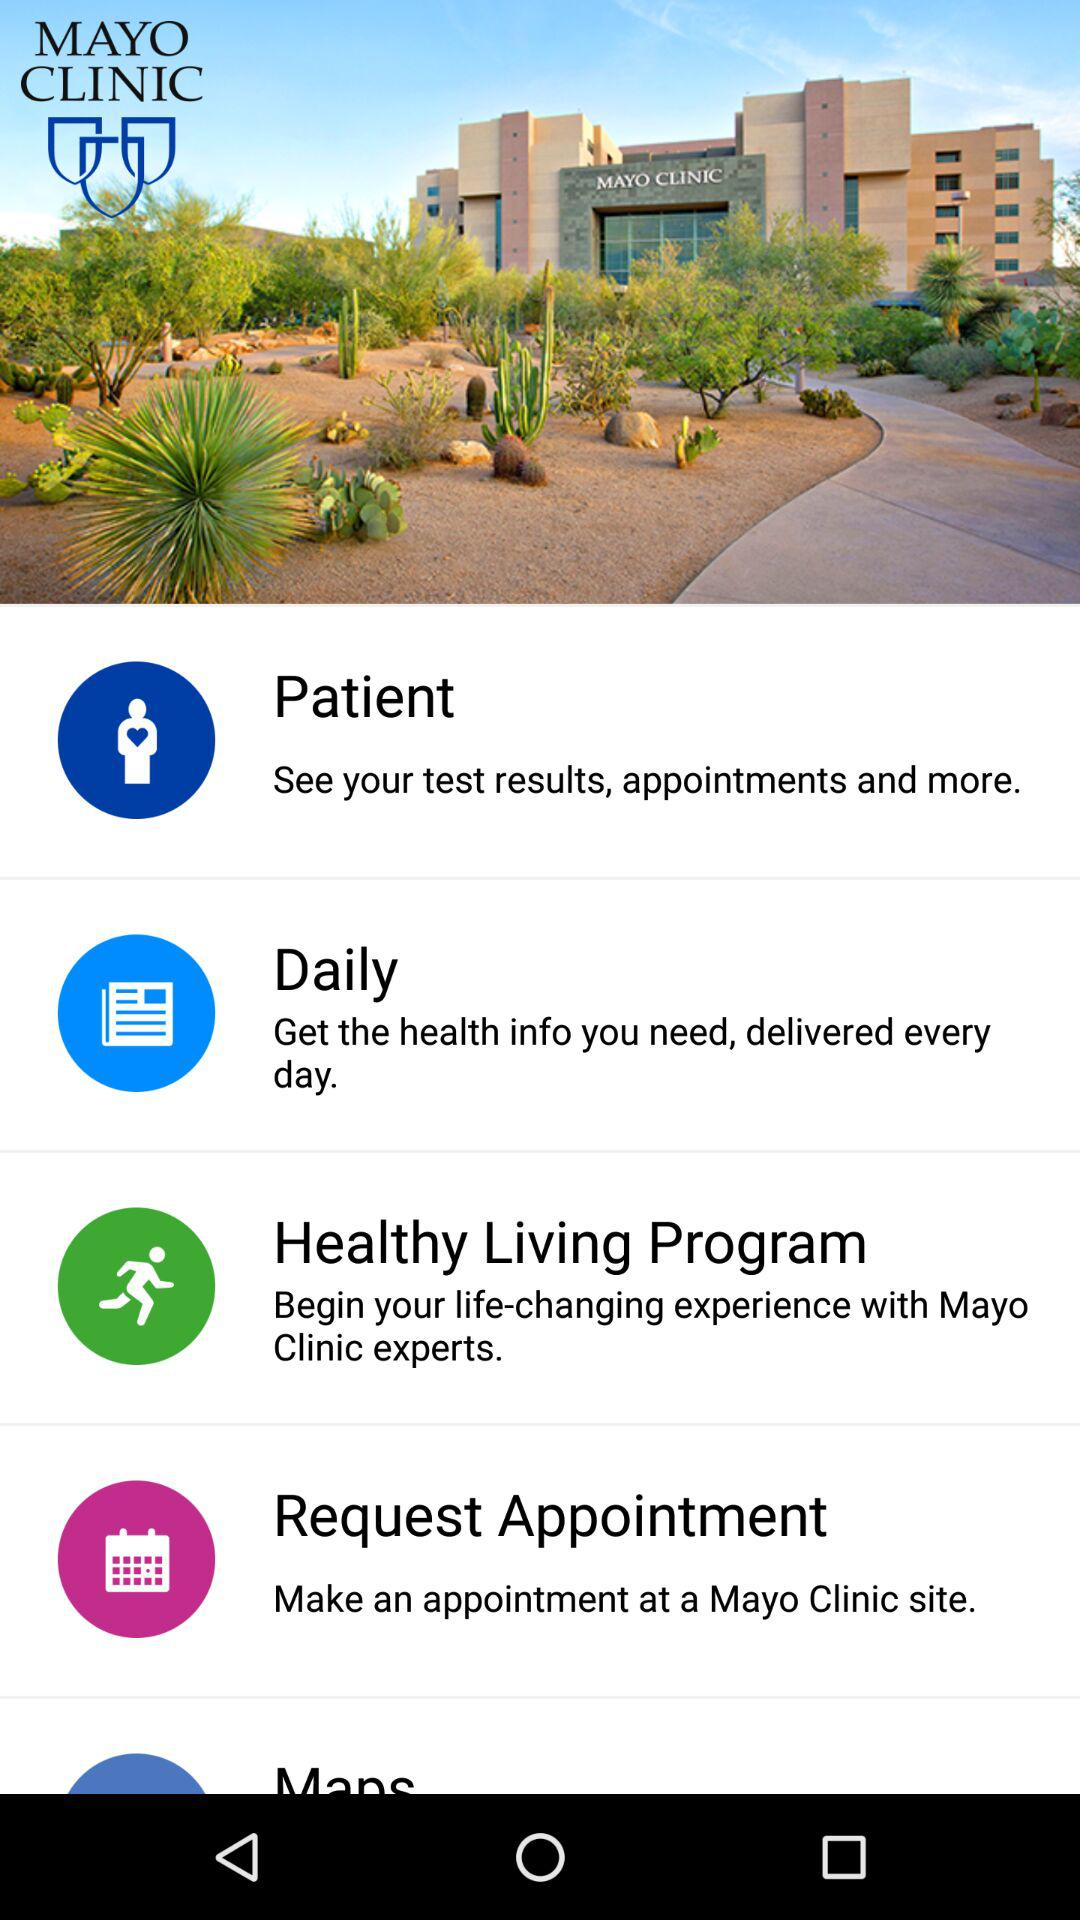What are the features available in "MAYO CLINIC"? The available features are "Patient", "Daily", "Healthy Living Program" and "Request Appointment". 